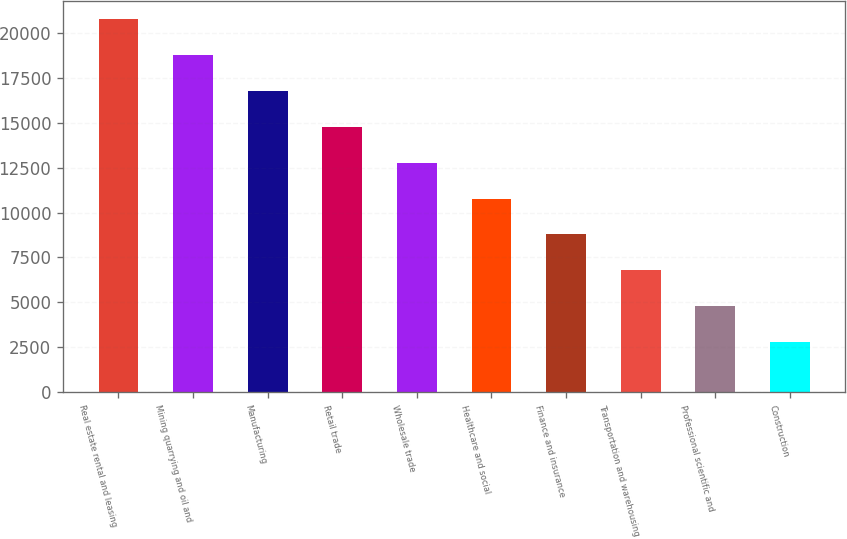<chart> <loc_0><loc_0><loc_500><loc_500><bar_chart><fcel>Real estate rental and leasing<fcel>Mining quarrying and oil and<fcel>Manufacturing<fcel>Retail trade<fcel>Wholesale trade<fcel>Healthcare and social<fcel>Finance and insurance<fcel>Transportation and warehousing<fcel>Professional scientific and<fcel>Construction<nl><fcel>20755<fcel>18759.4<fcel>16763.8<fcel>14768.2<fcel>12772.6<fcel>10777<fcel>8781.4<fcel>6785.8<fcel>4790.2<fcel>2794.6<nl></chart> 